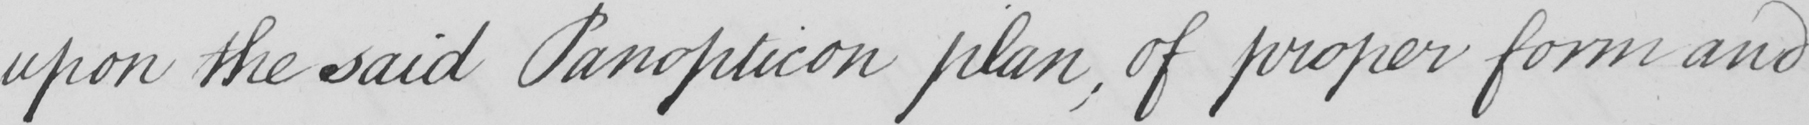Can you tell me what this handwritten text says? upon the said Panopticon plan , of proper form and 